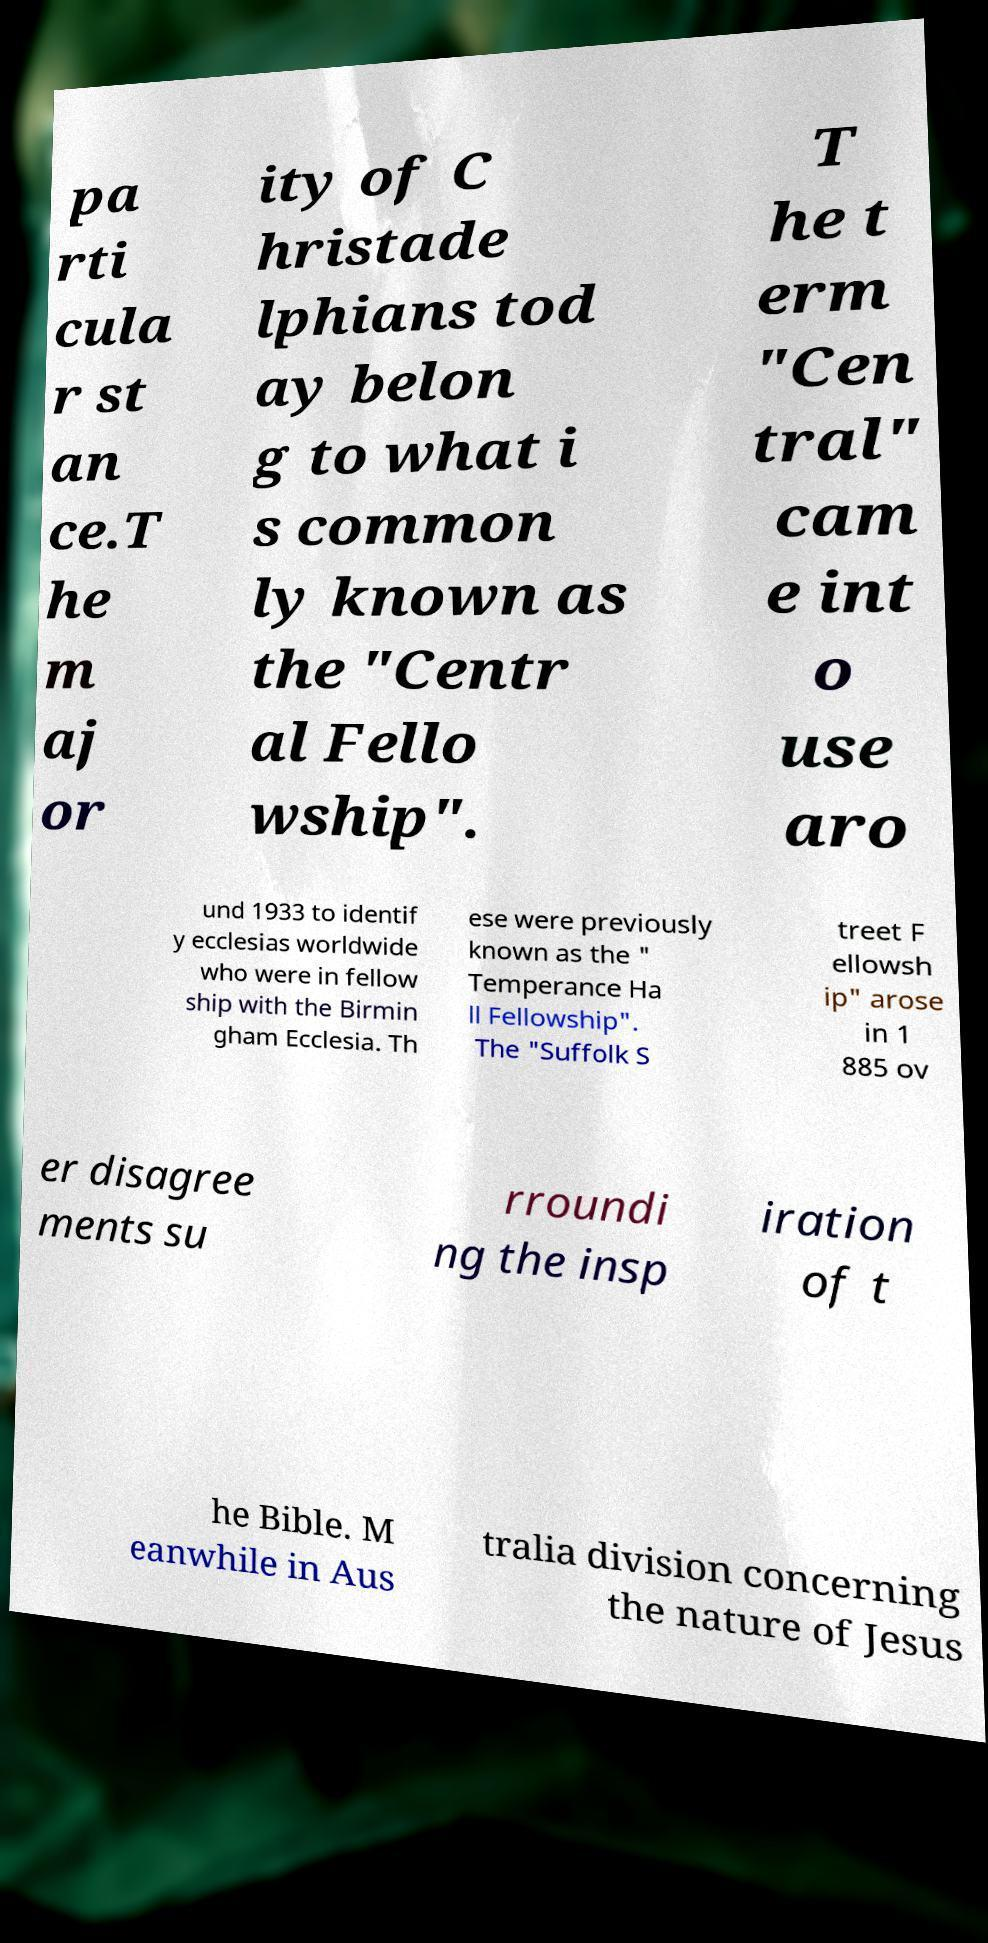I need the written content from this picture converted into text. Can you do that? pa rti cula r st an ce.T he m aj or ity of C hristade lphians tod ay belon g to what i s common ly known as the "Centr al Fello wship". T he t erm "Cen tral" cam e int o use aro und 1933 to identif y ecclesias worldwide who were in fellow ship with the Birmin gham Ecclesia. Th ese were previously known as the " Temperance Ha ll Fellowship". The "Suffolk S treet F ellowsh ip" arose in 1 885 ov er disagree ments su rroundi ng the insp iration of t he Bible. M eanwhile in Aus tralia division concerning the nature of Jesus 